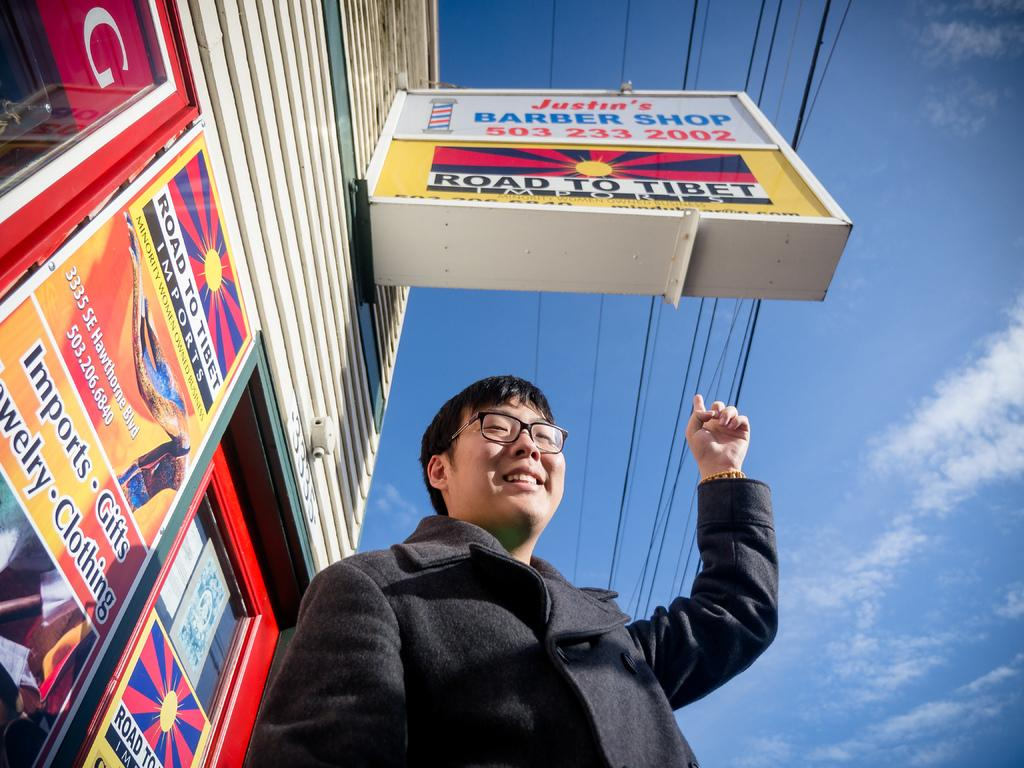Provide a one-sentence caption for the provided image. A man points at a Road to Tibet sign on the street. 